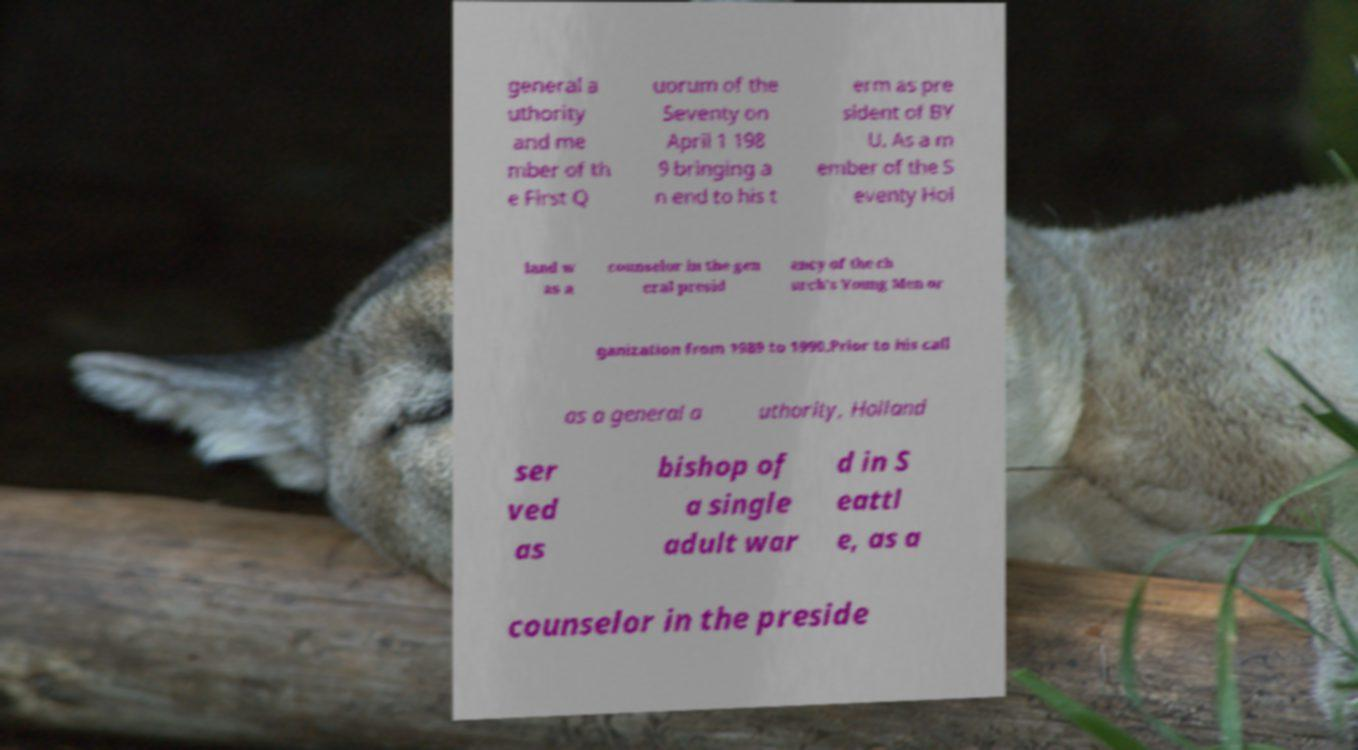Please read and relay the text visible in this image. What does it say? general a uthority and me mber of th e First Q uorum of the Seventy on April 1 198 9 bringing a n end to his t erm as pre sident of BY U. As a m ember of the S eventy Hol land w as a counselor in the gen eral presid ency of the ch urch's Young Men or ganization from 1989 to 1990.Prior to his call as a general a uthority, Holland ser ved as bishop of a single adult war d in S eattl e, as a counselor in the preside 